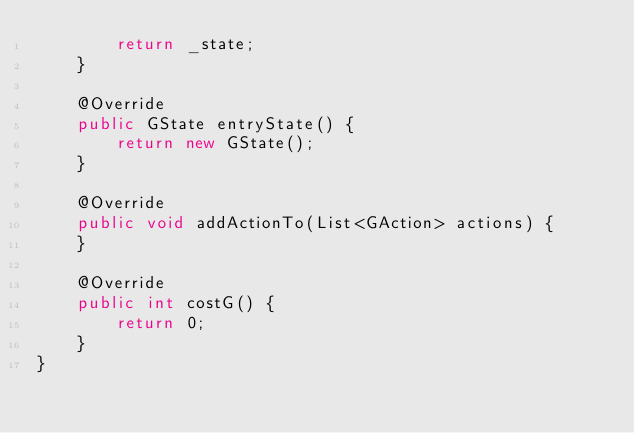<code> <loc_0><loc_0><loc_500><loc_500><_Java_>		return _state;
	}
	
	@Override
	public GState entryState() {
		return new GState();
	}

	@Override
	public void addActionTo(List<GAction> actions) {
	}

	@Override
	public int costG() {
		return 0;
	}
}
</code> 